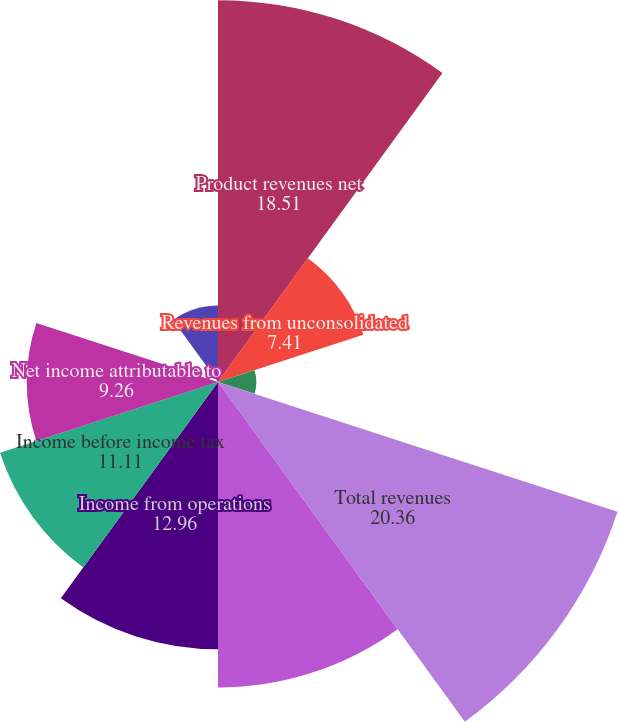Convert chart. <chart><loc_0><loc_0><loc_500><loc_500><pie_chart><fcel>Product revenues net<fcel>Revenues from unconsolidated<fcel>Other revenues<fcel>Total revenues<fcel>Total cost and expenses<fcel>Income from operations<fcel>Income before income tax<fcel>Net income attributable to<fcel>Diluted earnings per share<fcel>Weighted-average shares used<nl><fcel>18.51%<fcel>7.41%<fcel>1.86%<fcel>20.36%<fcel>14.81%<fcel>12.96%<fcel>11.11%<fcel>9.26%<fcel>0.01%<fcel>3.71%<nl></chart> 